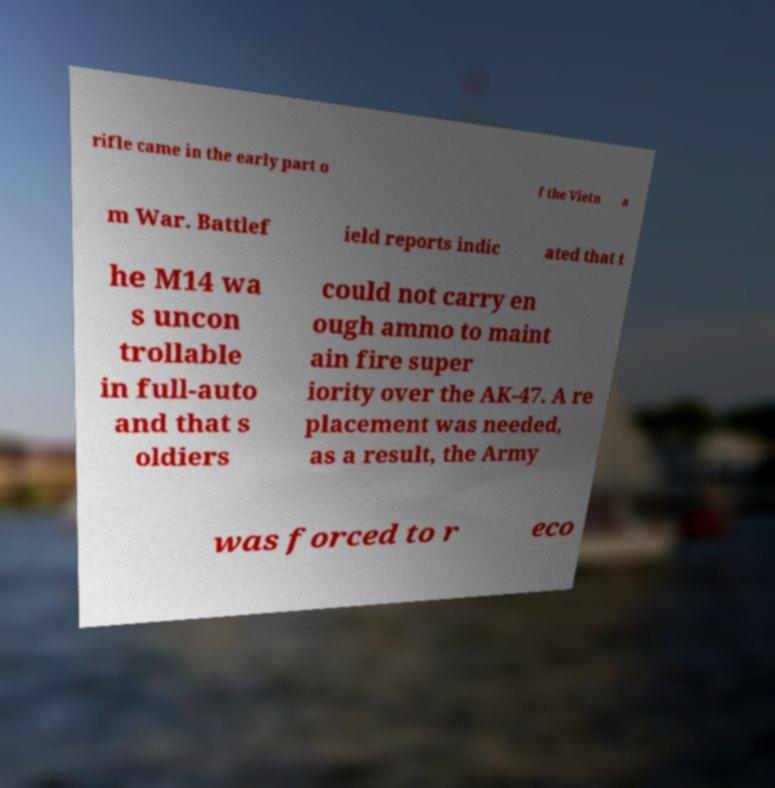There's text embedded in this image that I need extracted. Can you transcribe it verbatim? rifle came in the early part o f the Vietn a m War. Battlef ield reports indic ated that t he M14 wa s uncon trollable in full-auto and that s oldiers could not carry en ough ammo to maint ain fire super iority over the AK-47. A re placement was needed, as a result, the Army was forced to r eco 